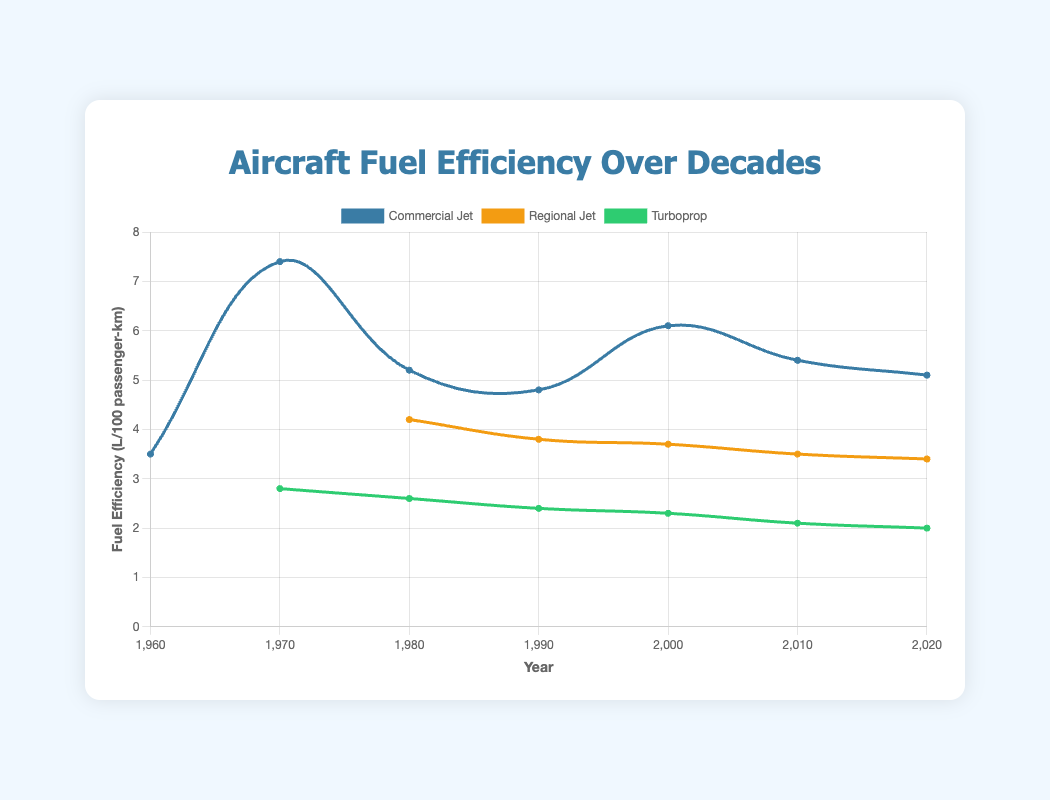Which aircraft type has shown the best fuel efficiency in 2020? The data points in 2020 shown on the chart for each aircraft type have different efficiency readings. By observing the values, the Turboprop in 2020 shows the best fuel efficiency with the value 2.0 L/100 passenger-km.
Answer: Turboprop What is the overall trend in fuel efficiency for Regional Jets from 1980 to 2020? By plotting the fuel efficiency values for Regional Jets from each decade (4.2 in 1980, 3.8 in 1990, 3.7 in 2000, 3.5 in 2010, and 3.4 in 2020), it's clear that the trend is a gradual improvement, denoted by decreasing values.
Answer: Gradual improvement Which Commercial Jet model was introduced in the 1970s and what was its fuel efficiency? Observing the chart for aircraft models and fuel efficiencies in 1970 under the category Commercial Jet, the Boeing 747 was introduced in that decade with a fuel efficiency of 7.4 L/100 passenger-km.
Answer: Boeing 747 - 7.4 Between 1970 and 2000, by how much did fuel efficiency improve for Commercial Jets? From the chart, for Commercial Jets, the fuel efficiency readings in 1970 are 7.4 and in 2000 are 6.1. Subtracting these values gives the improvement: 7.4 - 6.1 = 1.3.
Answer: Improved by 1.3 L/100 passenger-km Which aircraft type, according to the color representation on the graph, has the most consistent improvement over decades in fuel efficiency? Observing the line colors, Turboprops (green line) have the most consistent improvement with values decreasing steadily from 2.8 to 2.0 from 1970 to 2020.
Answer: Turboprop What is the average fuel efficiency of Turboprops in 1980 and 2020? From the chart, Turboprops have efficiencies of 2.6 in 1980 and 2.0 in 2020. The average is calculated as (2.6 + 2.0) / 2 = 2.3.
Answer: 2.3 How did the fuel efficiency of the Airbus A320 compare to the Boeing 767 in the 1990s? According to the chart, in the 1990s, the Airbus A320 had a fuel efficiency of 4.8, while the Boeing 767 had a fuel efficiency of 5.2. This shows Airbus A320 had a better (lower) fuel efficiency than Boeing 767.
Answer: Airbus A320 was better by 0.4 L/100 passenger-km What is the trend of fuel efficiency for Commercial Jets from 1960 to 2020? By listing the fuel efficiency values for Commercial Jets each decade (3.5 in 1960, 7.4 in 1970, 5.2 in 1980, 4.8 in 1990, 6.1 in 2000, 5.4 in 2010, and 5.1 in 2020), the overall trend shows a fluctuating improvement with an initial increase and later gradual decrease.
Answer: Fluctuating improvement What color represents Regional Jets on the graph? By observing the colors associated with each aircraft type's dataset on the chart, Regional Jets are shown in yellow.
Answer: Yellow 